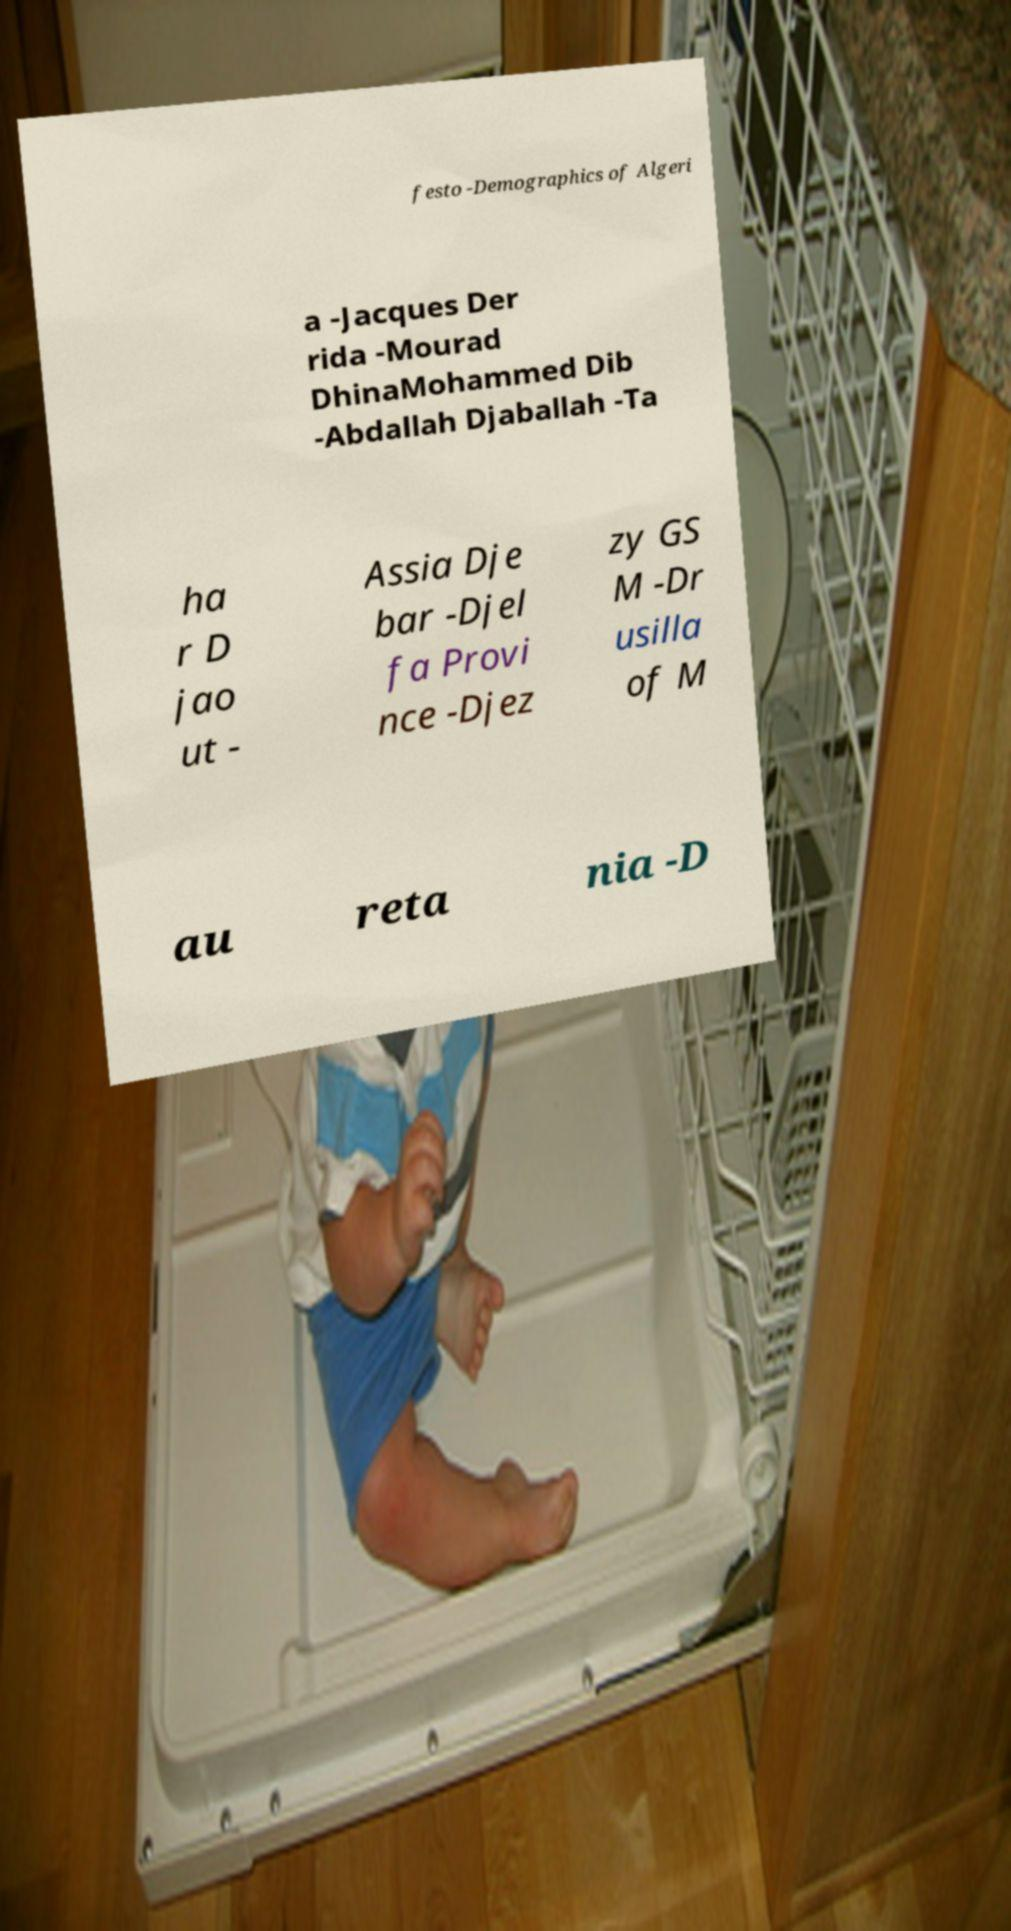For documentation purposes, I need the text within this image transcribed. Could you provide that? festo -Demographics of Algeri a -Jacques Der rida -Mourad DhinaMohammed Dib -Abdallah Djaballah -Ta ha r D jao ut - Assia Dje bar -Djel fa Provi nce -Djez zy GS M -Dr usilla of M au reta nia -D 